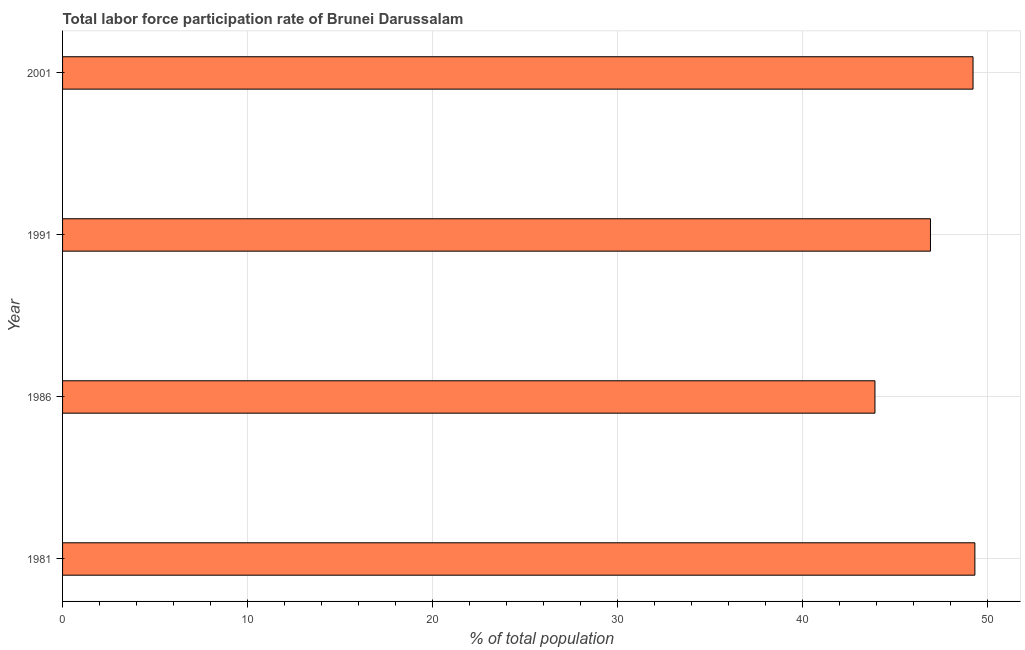Does the graph contain grids?
Provide a short and direct response. Yes. What is the title of the graph?
Keep it short and to the point. Total labor force participation rate of Brunei Darussalam. What is the label or title of the X-axis?
Offer a terse response. % of total population. What is the label or title of the Y-axis?
Your answer should be very brief. Year. What is the total labor force participation rate in 1986?
Make the answer very short. 43.9. Across all years, what is the maximum total labor force participation rate?
Keep it short and to the point. 49.3. Across all years, what is the minimum total labor force participation rate?
Your answer should be very brief. 43.9. In which year was the total labor force participation rate maximum?
Provide a short and direct response. 1981. In which year was the total labor force participation rate minimum?
Your response must be concise. 1986. What is the sum of the total labor force participation rate?
Provide a short and direct response. 189.3. What is the average total labor force participation rate per year?
Give a very brief answer. 47.33. What is the median total labor force participation rate?
Ensure brevity in your answer.  48.05. In how many years, is the total labor force participation rate greater than 4 %?
Offer a very short reply. 4. Do a majority of the years between 1986 and 2001 (inclusive) have total labor force participation rate greater than 34 %?
Your answer should be very brief. Yes. What is the ratio of the total labor force participation rate in 1981 to that in 2001?
Give a very brief answer. 1. Is the difference between the total labor force participation rate in 1986 and 1991 greater than the difference between any two years?
Your answer should be compact. No. What is the difference between the highest and the second highest total labor force participation rate?
Ensure brevity in your answer.  0.1. Is the sum of the total labor force participation rate in 1991 and 2001 greater than the maximum total labor force participation rate across all years?
Offer a very short reply. Yes. What is the difference between the highest and the lowest total labor force participation rate?
Provide a short and direct response. 5.4. In how many years, is the total labor force participation rate greater than the average total labor force participation rate taken over all years?
Keep it short and to the point. 2. Are all the bars in the graph horizontal?
Give a very brief answer. Yes. How many years are there in the graph?
Provide a succinct answer. 4. What is the % of total population of 1981?
Give a very brief answer. 49.3. What is the % of total population of 1986?
Offer a very short reply. 43.9. What is the % of total population in 1991?
Offer a terse response. 46.9. What is the % of total population of 2001?
Your answer should be very brief. 49.2. What is the difference between the % of total population in 1981 and 1986?
Provide a short and direct response. 5.4. What is the ratio of the % of total population in 1981 to that in 1986?
Your response must be concise. 1.12. What is the ratio of the % of total population in 1981 to that in 1991?
Provide a succinct answer. 1.05. What is the ratio of the % of total population in 1986 to that in 1991?
Ensure brevity in your answer.  0.94. What is the ratio of the % of total population in 1986 to that in 2001?
Ensure brevity in your answer.  0.89. What is the ratio of the % of total population in 1991 to that in 2001?
Offer a terse response. 0.95. 